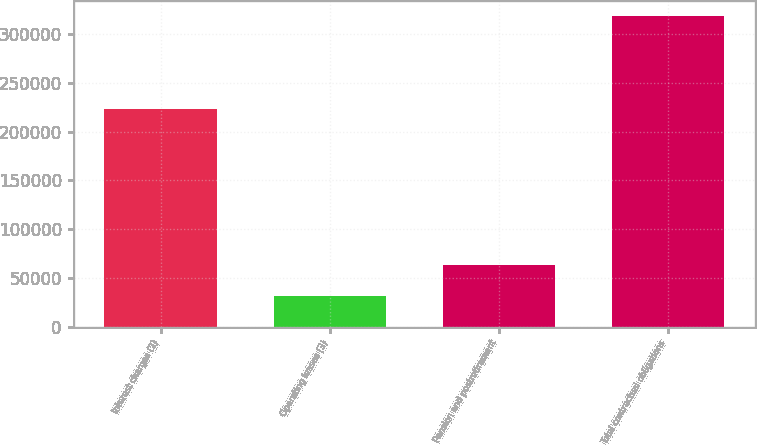<chart> <loc_0><loc_0><loc_500><loc_500><bar_chart><fcel>Interest charges (2)<fcel>Operating leases (3)<fcel>Pension and postretirement<fcel>Total contractual obligations<nl><fcel>222759<fcel>31625<fcel>63525<fcel>317909<nl></chart> 